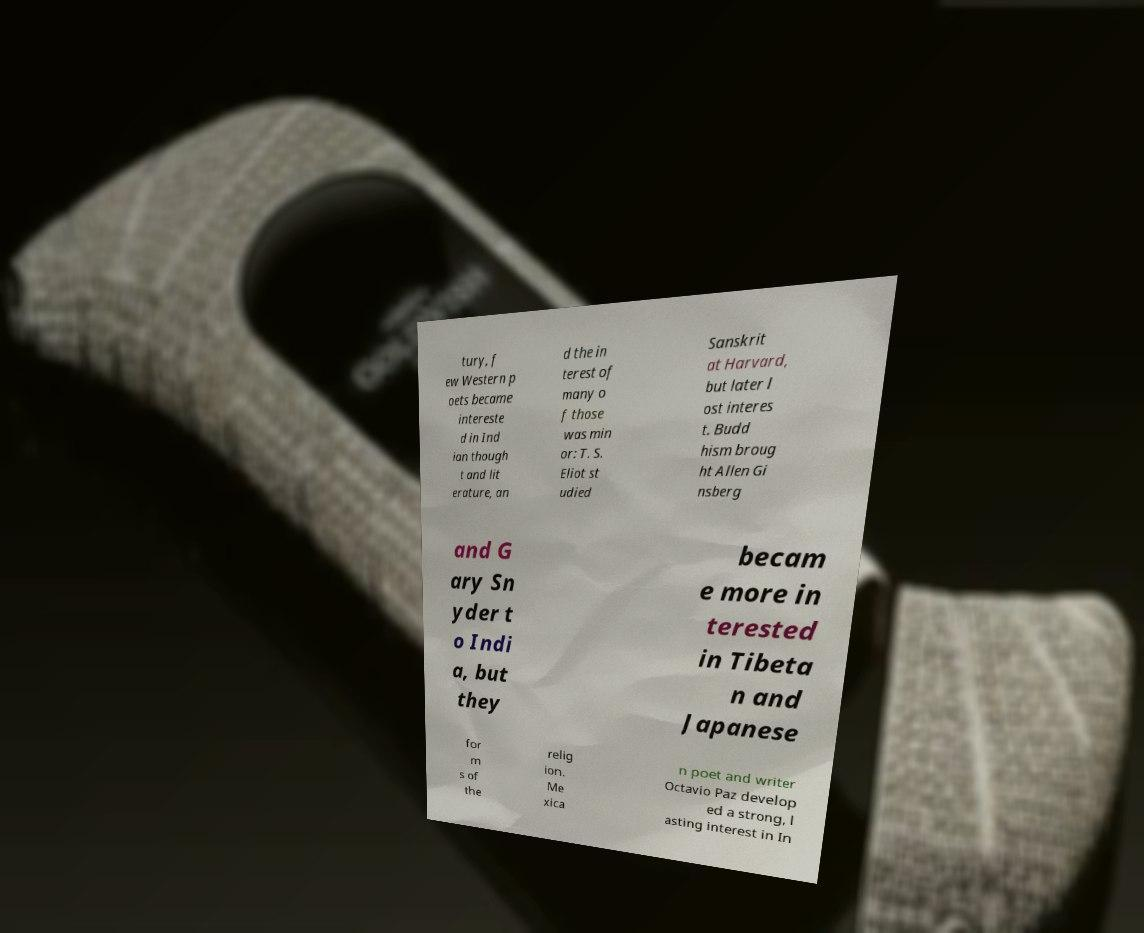I need the written content from this picture converted into text. Can you do that? tury, f ew Western p oets became intereste d in Ind ian though t and lit erature, an d the in terest of many o f those was min or: T. S. Eliot st udied Sanskrit at Harvard, but later l ost interes t. Budd hism broug ht Allen Gi nsberg and G ary Sn yder t o Indi a, but they becam e more in terested in Tibeta n and Japanese for m s of the relig ion. Me xica n poet and writer Octavio Paz develop ed a strong, l asting interest in In 